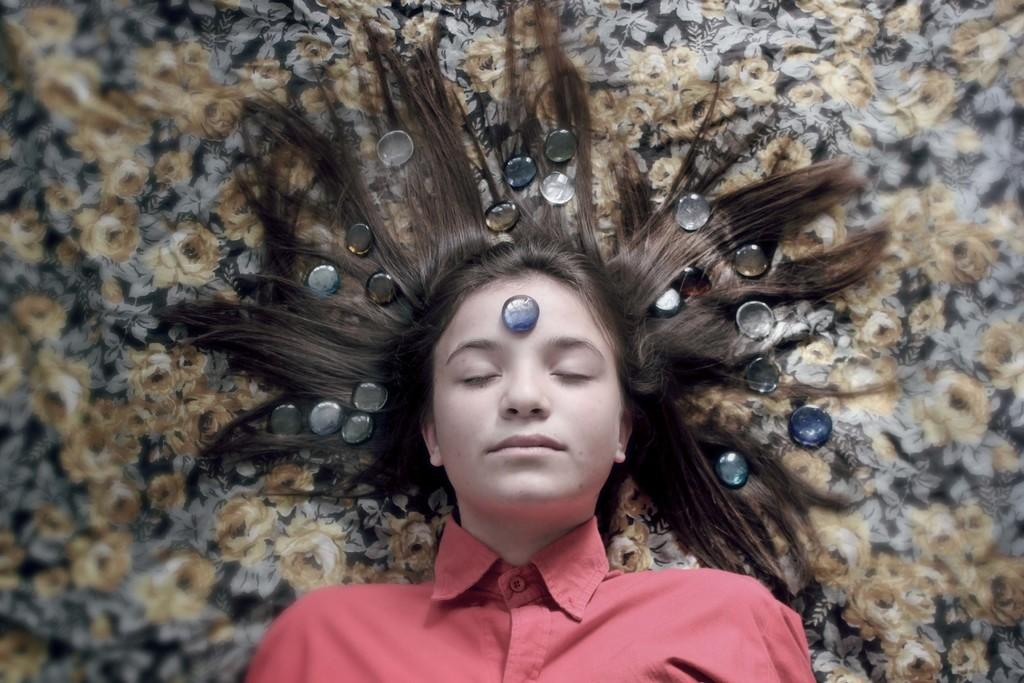What is the person in the image doing? The person is sleeping on the ground. What can be seen on the person's forehead? There is a stone on the person's forehead. What else is placed on the person's head? There is a stone on the person's hair. What colors can be seen in the cloth in the background? The cloth in the background has yellow and black colors. What type of crate is being used to store the son in the image? There is no son or crate present in the image. 